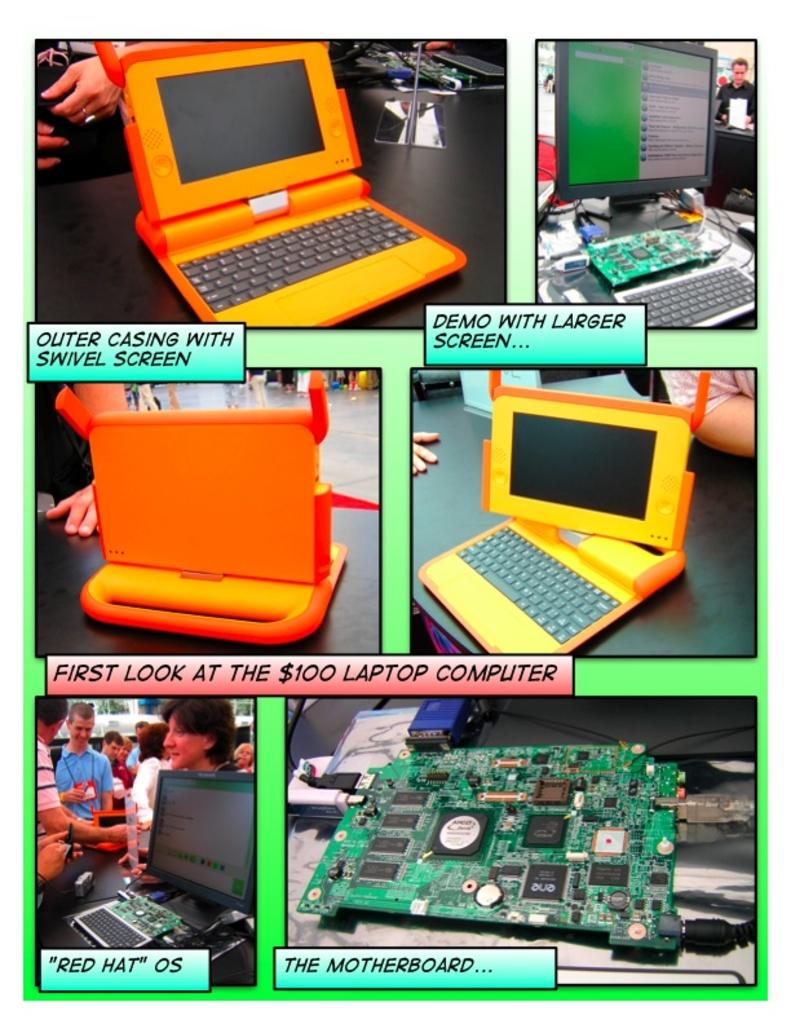<image>
Relay a brief, clear account of the picture shown. An ad depicting the "First look at the $100 laptop computer" and showing off its features, including the motherboard. 